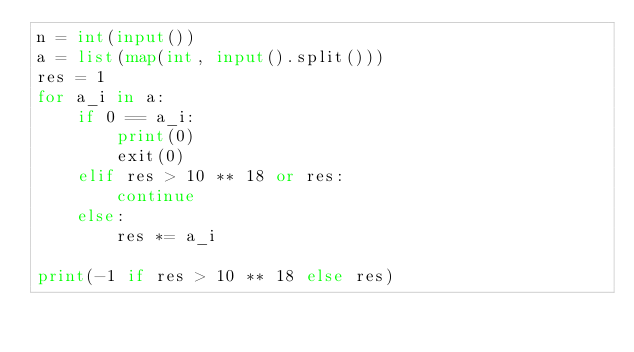Convert code to text. <code><loc_0><loc_0><loc_500><loc_500><_Python_>n = int(input())
a = list(map(int, input().split()))
res = 1
for a_i in a:
    if 0 == a_i:
        print(0)
        exit(0)
    elif res > 10 ** 18 or res:
        continue
    else:
        res *= a_i

print(-1 if res > 10 ** 18 else res)
</code> 